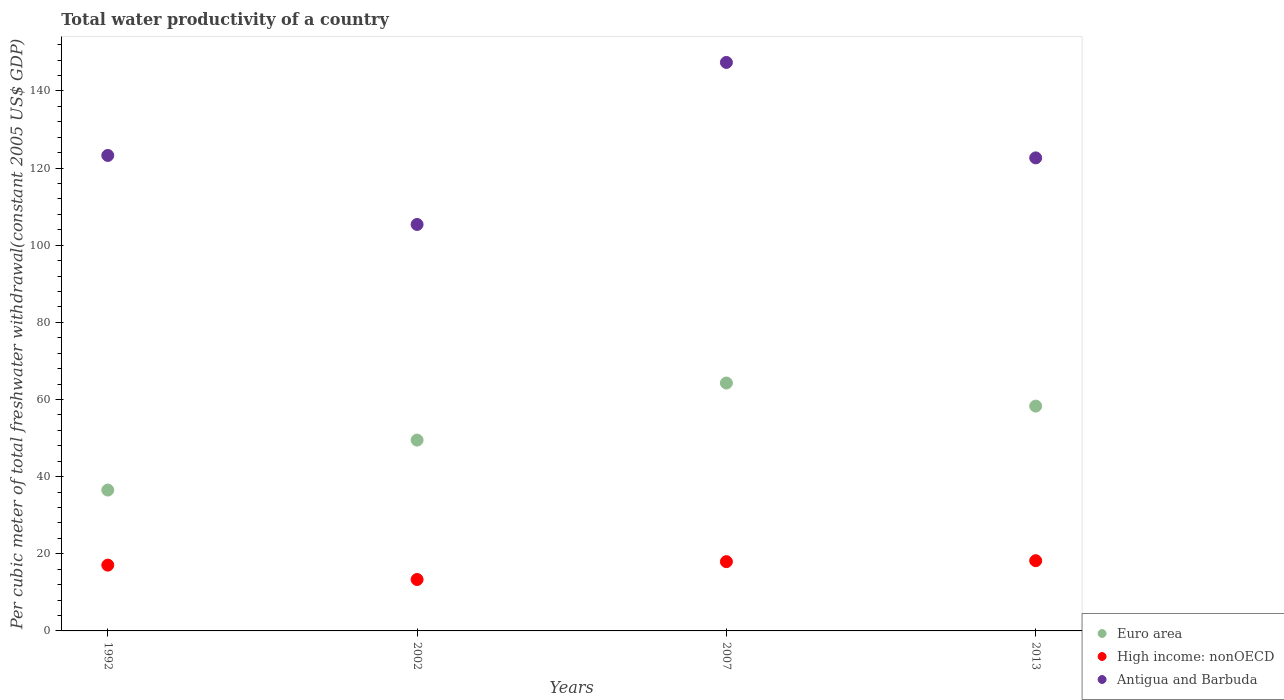How many different coloured dotlines are there?
Make the answer very short. 3. What is the total water productivity in High income: nonOECD in 2002?
Make the answer very short. 13.33. Across all years, what is the maximum total water productivity in Antigua and Barbuda?
Make the answer very short. 147.4. Across all years, what is the minimum total water productivity in Antigua and Barbuda?
Your answer should be compact. 105.39. In which year was the total water productivity in Antigua and Barbuda minimum?
Your answer should be very brief. 2002. What is the total total water productivity in Antigua and Barbuda in the graph?
Keep it short and to the point. 498.73. What is the difference between the total water productivity in Antigua and Barbuda in 1992 and that in 2002?
Provide a succinct answer. 17.89. What is the difference between the total water productivity in Antigua and Barbuda in 2002 and the total water productivity in Euro area in 1992?
Make the answer very short. 68.87. What is the average total water productivity in Antigua and Barbuda per year?
Offer a terse response. 124.68. In the year 2002, what is the difference between the total water productivity in Euro area and total water productivity in High income: nonOECD?
Ensure brevity in your answer.  36.15. In how many years, is the total water productivity in Antigua and Barbuda greater than 60 US$?
Give a very brief answer. 4. What is the ratio of the total water productivity in Euro area in 2002 to that in 2013?
Your answer should be very brief. 0.85. Is the total water productivity in High income: nonOECD in 2002 less than that in 2013?
Offer a very short reply. Yes. What is the difference between the highest and the second highest total water productivity in High income: nonOECD?
Your answer should be very brief. 0.25. What is the difference between the highest and the lowest total water productivity in High income: nonOECD?
Give a very brief answer. 4.87. In how many years, is the total water productivity in Euro area greater than the average total water productivity in Euro area taken over all years?
Provide a succinct answer. 2. Is the sum of the total water productivity in Antigua and Barbuda in 1992 and 2002 greater than the maximum total water productivity in Euro area across all years?
Your answer should be very brief. Yes. Is it the case that in every year, the sum of the total water productivity in High income: nonOECD and total water productivity in Euro area  is greater than the total water productivity in Antigua and Barbuda?
Provide a short and direct response. No. Does the total water productivity in High income: nonOECD monotonically increase over the years?
Your response must be concise. No. Is the total water productivity in Antigua and Barbuda strictly greater than the total water productivity in High income: nonOECD over the years?
Provide a short and direct response. Yes. How many dotlines are there?
Offer a very short reply. 3. Does the graph contain any zero values?
Keep it short and to the point. No. How many legend labels are there?
Keep it short and to the point. 3. How are the legend labels stacked?
Keep it short and to the point. Vertical. What is the title of the graph?
Provide a succinct answer. Total water productivity of a country. Does "Cote d'Ivoire" appear as one of the legend labels in the graph?
Your answer should be very brief. No. What is the label or title of the Y-axis?
Make the answer very short. Per cubic meter of total freshwater withdrawal(constant 2005 US$ GDP). What is the Per cubic meter of total freshwater withdrawal(constant 2005 US$ GDP) of Euro area in 1992?
Provide a succinct answer. 36.52. What is the Per cubic meter of total freshwater withdrawal(constant 2005 US$ GDP) of High income: nonOECD in 1992?
Keep it short and to the point. 17.06. What is the Per cubic meter of total freshwater withdrawal(constant 2005 US$ GDP) in Antigua and Barbuda in 1992?
Your response must be concise. 123.28. What is the Per cubic meter of total freshwater withdrawal(constant 2005 US$ GDP) of Euro area in 2002?
Provide a succinct answer. 49.48. What is the Per cubic meter of total freshwater withdrawal(constant 2005 US$ GDP) in High income: nonOECD in 2002?
Keep it short and to the point. 13.33. What is the Per cubic meter of total freshwater withdrawal(constant 2005 US$ GDP) in Antigua and Barbuda in 2002?
Provide a succinct answer. 105.39. What is the Per cubic meter of total freshwater withdrawal(constant 2005 US$ GDP) in Euro area in 2007?
Your answer should be very brief. 64.27. What is the Per cubic meter of total freshwater withdrawal(constant 2005 US$ GDP) of High income: nonOECD in 2007?
Give a very brief answer. 17.96. What is the Per cubic meter of total freshwater withdrawal(constant 2005 US$ GDP) in Antigua and Barbuda in 2007?
Give a very brief answer. 147.4. What is the Per cubic meter of total freshwater withdrawal(constant 2005 US$ GDP) in Euro area in 2013?
Your answer should be compact. 58.3. What is the Per cubic meter of total freshwater withdrawal(constant 2005 US$ GDP) in High income: nonOECD in 2013?
Your answer should be compact. 18.21. What is the Per cubic meter of total freshwater withdrawal(constant 2005 US$ GDP) in Antigua and Barbuda in 2013?
Provide a succinct answer. 122.66. Across all years, what is the maximum Per cubic meter of total freshwater withdrawal(constant 2005 US$ GDP) in Euro area?
Ensure brevity in your answer.  64.27. Across all years, what is the maximum Per cubic meter of total freshwater withdrawal(constant 2005 US$ GDP) of High income: nonOECD?
Provide a succinct answer. 18.21. Across all years, what is the maximum Per cubic meter of total freshwater withdrawal(constant 2005 US$ GDP) in Antigua and Barbuda?
Offer a very short reply. 147.4. Across all years, what is the minimum Per cubic meter of total freshwater withdrawal(constant 2005 US$ GDP) of Euro area?
Keep it short and to the point. 36.52. Across all years, what is the minimum Per cubic meter of total freshwater withdrawal(constant 2005 US$ GDP) of High income: nonOECD?
Offer a very short reply. 13.33. Across all years, what is the minimum Per cubic meter of total freshwater withdrawal(constant 2005 US$ GDP) of Antigua and Barbuda?
Keep it short and to the point. 105.39. What is the total Per cubic meter of total freshwater withdrawal(constant 2005 US$ GDP) in Euro area in the graph?
Give a very brief answer. 208.57. What is the total Per cubic meter of total freshwater withdrawal(constant 2005 US$ GDP) of High income: nonOECD in the graph?
Provide a short and direct response. 66.56. What is the total Per cubic meter of total freshwater withdrawal(constant 2005 US$ GDP) in Antigua and Barbuda in the graph?
Offer a terse response. 498.73. What is the difference between the Per cubic meter of total freshwater withdrawal(constant 2005 US$ GDP) in Euro area in 1992 and that in 2002?
Your response must be concise. -12.96. What is the difference between the Per cubic meter of total freshwater withdrawal(constant 2005 US$ GDP) in High income: nonOECD in 1992 and that in 2002?
Make the answer very short. 3.72. What is the difference between the Per cubic meter of total freshwater withdrawal(constant 2005 US$ GDP) in Antigua and Barbuda in 1992 and that in 2002?
Provide a short and direct response. 17.89. What is the difference between the Per cubic meter of total freshwater withdrawal(constant 2005 US$ GDP) in Euro area in 1992 and that in 2007?
Keep it short and to the point. -27.75. What is the difference between the Per cubic meter of total freshwater withdrawal(constant 2005 US$ GDP) of High income: nonOECD in 1992 and that in 2007?
Provide a succinct answer. -0.9. What is the difference between the Per cubic meter of total freshwater withdrawal(constant 2005 US$ GDP) in Antigua and Barbuda in 1992 and that in 2007?
Ensure brevity in your answer.  -24.12. What is the difference between the Per cubic meter of total freshwater withdrawal(constant 2005 US$ GDP) in Euro area in 1992 and that in 2013?
Make the answer very short. -21.77. What is the difference between the Per cubic meter of total freshwater withdrawal(constant 2005 US$ GDP) of High income: nonOECD in 1992 and that in 2013?
Give a very brief answer. -1.15. What is the difference between the Per cubic meter of total freshwater withdrawal(constant 2005 US$ GDP) of Antigua and Barbuda in 1992 and that in 2013?
Keep it short and to the point. 0.63. What is the difference between the Per cubic meter of total freshwater withdrawal(constant 2005 US$ GDP) of Euro area in 2002 and that in 2007?
Give a very brief answer. -14.79. What is the difference between the Per cubic meter of total freshwater withdrawal(constant 2005 US$ GDP) in High income: nonOECD in 2002 and that in 2007?
Offer a terse response. -4.63. What is the difference between the Per cubic meter of total freshwater withdrawal(constant 2005 US$ GDP) of Antigua and Barbuda in 2002 and that in 2007?
Ensure brevity in your answer.  -42.02. What is the difference between the Per cubic meter of total freshwater withdrawal(constant 2005 US$ GDP) of Euro area in 2002 and that in 2013?
Provide a succinct answer. -8.82. What is the difference between the Per cubic meter of total freshwater withdrawal(constant 2005 US$ GDP) in High income: nonOECD in 2002 and that in 2013?
Make the answer very short. -4.87. What is the difference between the Per cubic meter of total freshwater withdrawal(constant 2005 US$ GDP) of Antigua and Barbuda in 2002 and that in 2013?
Keep it short and to the point. -17.27. What is the difference between the Per cubic meter of total freshwater withdrawal(constant 2005 US$ GDP) of Euro area in 2007 and that in 2013?
Offer a terse response. 5.98. What is the difference between the Per cubic meter of total freshwater withdrawal(constant 2005 US$ GDP) of High income: nonOECD in 2007 and that in 2013?
Make the answer very short. -0.25. What is the difference between the Per cubic meter of total freshwater withdrawal(constant 2005 US$ GDP) in Antigua and Barbuda in 2007 and that in 2013?
Ensure brevity in your answer.  24.75. What is the difference between the Per cubic meter of total freshwater withdrawal(constant 2005 US$ GDP) in Euro area in 1992 and the Per cubic meter of total freshwater withdrawal(constant 2005 US$ GDP) in High income: nonOECD in 2002?
Your answer should be compact. 23.19. What is the difference between the Per cubic meter of total freshwater withdrawal(constant 2005 US$ GDP) of Euro area in 1992 and the Per cubic meter of total freshwater withdrawal(constant 2005 US$ GDP) of Antigua and Barbuda in 2002?
Keep it short and to the point. -68.87. What is the difference between the Per cubic meter of total freshwater withdrawal(constant 2005 US$ GDP) of High income: nonOECD in 1992 and the Per cubic meter of total freshwater withdrawal(constant 2005 US$ GDP) of Antigua and Barbuda in 2002?
Make the answer very short. -88.33. What is the difference between the Per cubic meter of total freshwater withdrawal(constant 2005 US$ GDP) in Euro area in 1992 and the Per cubic meter of total freshwater withdrawal(constant 2005 US$ GDP) in High income: nonOECD in 2007?
Ensure brevity in your answer.  18.56. What is the difference between the Per cubic meter of total freshwater withdrawal(constant 2005 US$ GDP) of Euro area in 1992 and the Per cubic meter of total freshwater withdrawal(constant 2005 US$ GDP) of Antigua and Barbuda in 2007?
Ensure brevity in your answer.  -110.88. What is the difference between the Per cubic meter of total freshwater withdrawal(constant 2005 US$ GDP) in High income: nonOECD in 1992 and the Per cubic meter of total freshwater withdrawal(constant 2005 US$ GDP) in Antigua and Barbuda in 2007?
Provide a succinct answer. -130.35. What is the difference between the Per cubic meter of total freshwater withdrawal(constant 2005 US$ GDP) in Euro area in 1992 and the Per cubic meter of total freshwater withdrawal(constant 2005 US$ GDP) in High income: nonOECD in 2013?
Keep it short and to the point. 18.31. What is the difference between the Per cubic meter of total freshwater withdrawal(constant 2005 US$ GDP) of Euro area in 1992 and the Per cubic meter of total freshwater withdrawal(constant 2005 US$ GDP) of Antigua and Barbuda in 2013?
Your answer should be compact. -86.13. What is the difference between the Per cubic meter of total freshwater withdrawal(constant 2005 US$ GDP) in High income: nonOECD in 1992 and the Per cubic meter of total freshwater withdrawal(constant 2005 US$ GDP) in Antigua and Barbuda in 2013?
Your answer should be very brief. -105.6. What is the difference between the Per cubic meter of total freshwater withdrawal(constant 2005 US$ GDP) in Euro area in 2002 and the Per cubic meter of total freshwater withdrawal(constant 2005 US$ GDP) in High income: nonOECD in 2007?
Offer a terse response. 31.52. What is the difference between the Per cubic meter of total freshwater withdrawal(constant 2005 US$ GDP) in Euro area in 2002 and the Per cubic meter of total freshwater withdrawal(constant 2005 US$ GDP) in Antigua and Barbuda in 2007?
Provide a short and direct response. -97.92. What is the difference between the Per cubic meter of total freshwater withdrawal(constant 2005 US$ GDP) of High income: nonOECD in 2002 and the Per cubic meter of total freshwater withdrawal(constant 2005 US$ GDP) of Antigua and Barbuda in 2007?
Make the answer very short. -134.07. What is the difference between the Per cubic meter of total freshwater withdrawal(constant 2005 US$ GDP) of Euro area in 2002 and the Per cubic meter of total freshwater withdrawal(constant 2005 US$ GDP) of High income: nonOECD in 2013?
Provide a succinct answer. 31.27. What is the difference between the Per cubic meter of total freshwater withdrawal(constant 2005 US$ GDP) in Euro area in 2002 and the Per cubic meter of total freshwater withdrawal(constant 2005 US$ GDP) in Antigua and Barbuda in 2013?
Make the answer very short. -73.18. What is the difference between the Per cubic meter of total freshwater withdrawal(constant 2005 US$ GDP) in High income: nonOECD in 2002 and the Per cubic meter of total freshwater withdrawal(constant 2005 US$ GDP) in Antigua and Barbuda in 2013?
Ensure brevity in your answer.  -109.32. What is the difference between the Per cubic meter of total freshwater withdrawal(constant 2005 US$ GDP) in Euro area in 2007 and the Per cubic meter of total freshwater withdrawal(constant 2005 US$ GDP) in High income: nonOECD in 2013?
Provide a short and direct response. 46.07. What is the difference between the Per cubic meter of total freshwater withdrawal(constant 2005 US$ GDP) of Euro area in 2007 and the Per cubic meter of total freshwater withdrawal(constant 2005 US$ GDP) of Antigua and Barbuda in 2013?
Your answer should be compact. -58.38. What is the difference between the Per cubic meter of total freshwater withdrawal(constant 2005 US$ GDP) in High income: nonOECD in 2007 and the Per cubic meter of total freshwater withdrawal(constant 2005 US$ GDP) in Antigua and Barbuda in 2013?
Make the answer very short. -104.69. What is the average Per cubic meter of total freshwater withdrawal(constant 2005 US$ GDP) of Euro area per year?
Provide a succinct answer. 52.14. What is the average Per cubic meter of total freshwater withdrawal(constant 2005 US$ GDP) in High income: nonOECD per year?
Make the answer very short. 16.64. What is the average Per cubic meter of total freshwater withdrawal(constant 2005 US$ GDP) of Antigua and Barbuda per year?
Keep it short and to the point. 124.68. In the year 1992, what is the difference between the Per cubic meter of total freshwater withdrawal(constant 2005 US$ GDP) of Euro area and Per cubic meter of total freshwater withdrawal(constant 2005 US$ GDP) of High income: nonOECD?
Your answer should be very brief. 19.46. In the year 1992, what is the difference between the Per cubic meter of total freshwater withdrawal(constant 2005 US$ GDP) of Euro area and Per cubic meter of total freshwater withdrawal(constant 2005 US$ GDP) of Antigua and Barbuda?
Offer a terse response. -86.76. In the year 1992, what is the difference between the Per cubic meter of total freshwater withdrawal(constant 2005 US$ GDP) of High income: nonOECD and Per cubic meter of total freshwater withdrawal(constant 2005 US$ GDP) of Antigua and Barbuda?
Your answer should be compact. -106.22. In the year 2002, what is the difference between the Per cubic meter of total freshwater withdrawal(constant 2005 US$ GDP) of Euro area and Per cubic meter of total freshwater withdrawal(constant 2005 US$ GDP) of High income: nonOECD?
Your response must be concise. 36.15. In the year 2002, what is the difference between the Per cubic meter of total freshwater withdrawal(constant 2005 US$ GDP) of Euro area and Per cubic meter of total freshwater withdrawal(constant 2005 US$ GDP) of Antigua and Barbuda?
Provide a short and direct response. -55.91. In the year 2002, what is the difference between the Per cubic meter of total freshwater withdrawal(constant 2005 US$ GDP) in High income: nonOECD and Per cubic meter of total freshwater withdrawal(constant 2005 US$ GDP) in Antigua and Barbuda?
Your response must be concise. -92.06. In the year 2007, what is the difference between the Per cubic meter of total freshwater withdrawal(constant 2005 US$ GDP) in Euro area and Per cubic meter of total freshwater withdrawal(constant 2005 US$ GDP) in High income: nonOECD?
Ensure brevity in your answer.  46.31. In the year 2007, what is the difference between the Per cubic meter of total freshwater withdrawal(constant 2005 US$ GDP) of Euro area and Per cubic meter of total freshwater withdrawal(constant 2005 US$ GDP) of Antigua and Barbuda?
Offer a very short reply. -83.13. In the year 2007, what is the difference between the Per cubic meter of total freshwater withdrawal(constant 2005 US$ GDP) of High income: nonOECD and Per cubic meter of total freshwater withdrawal(constant 2005 US$ GDP) of Antigua and Barbuda?
Your answer should be very brief. -129.44. In the year 2013, what is the difference between the Per cubic meter of total freshwater withdrawal(constant 2005 US$ GDP) in Euro area and Per cubic meter of total freshwater withdrawal(constant 2005 US$ GDP) in High income: nonOECD?
Your response must be concise. 40.09. In the year 2013, what is the difference between the Per cubic meter of total freshwater withdrawal(constant 2005 US$ GDP) of Euro area and Per cubic meter of total freshwater withdrawal(constant 2005 US$ GDP) of Antigua and Barbuda?
Your response must be concise. -64.36. In the year 2013, what is the difference between the Per cubic meter of total freshwater withdrawal(constant 2005 US$ GDP) of High income: nonOECD and Per cubic meter of total freshwater withdrawal(constant 2005 US$ GDP) of Antigua and Barbuda?
Your answer should be very brief. -104.45. What is the ratio of the Per cubic meter of total freshwater withdrawal(constant 2005 US$ GDP) of Euro area in 1992 to that in 2002?
Offer a terse response. 0.74. What is the ratio of the Per cubic meter of total freshwater withdrawal(constant 2005 US$ GDP) of High income: nonOECD in 1992 to that in 2002?
Keep it short and to the point. 1.28. What is the ratio of the Per cubic meter of total freshwater withdrawal(constant 2005 US$ GDP) of Antigua and Barbuda in 1992 to that in 2002?
Your response must be concise. 1.17. What is the ratio of the Per cubic meter of total freshwater withdrawal(constant 2005 US$ GDP) of Euro area in 1992 to that in 2007?
Make the answer very short. 0.57. What is the ratio of the Per cubic meter of total freshwater withdrawal(constant 2005 US$ GDP) of High income: nonOECD in 1992 to that in 2007?
Your answer should be very brief. 0.95. What is the ratio of the Per cubic meter of total freshwater withdrawal(constant 2005 US$ GDP) in Antigua and Barbuda in 1992 to that in 2007?
Provide a succinct answer. 0.84. What is the ratio of the Per cubic meter of total freshwater withdrawal(constant 2005 US$ GDP) of Euro area in 1992 to that in 2013?
Keep it short and to the point. 0.63. What is the ratio of the Per cubic meter of total freshwater withdrawal(constant 2005 US$ GDP) of High income: nonOECD in 1992 to that in 2013?
Your answer should be compact. 0.94. What is the ratio of the Per cubic meter of total freshwater withdrawal(constant 2005 US$ GDP) in Antigua and Barbuda in 1992 to that in 2013?
Your answer should be compact. 1.01. What is the ratio of the Per cubic meter of total freshwater withdrawal(constant 2005 US$ GDP) of Euro area in 2002 to that in 2007?
Offer a terse response. 0.77. What is the ratio of the Per cubic meter of total freshwater withdrawal(constant 2005 US$ GDP) of High income: nonOECD in 2002 to that in 2007?
Provide a short and direct response. 0.74. What is the ratio of the Per cubic meter of total freshwater withdrawal(constant 2005 US$ GDP) of Antigua and Barbuda in 2002 to that in 2007?
Your answer should be compact. 0.71. What is the ratio of the Per cubic meter of total freshwater withdrawal(constant 2005 US$ GDP) of Euro area in 2002 to that in 2013?
Make the answer very short. 0.85. What is the ratio of the Per cubic meter of total freshwater withdrawal(constant 2005 US$ GDP) of High income: nonOECD in 2002 to that in 2013?
Give a very brief answer. 0.73. What is the ratio of the Per cubic meter of total freshwater withdrawal(constant 2005 US$ GDP) of Antigua and Barbuda in 2002 to that in 2013?
Offer a very short reply. 0.86. What is the ratio of the Per cubic meter of total freshwater withdrawal(constant 2005 US$ GDP) of Euro area in 2007 to that in 2013?
Ensure brevity in your answer.  1.1. What is the ratio of the Per cubic meter of total freshwater withdrawal(constant 2005 US$ GDP) of High income: nonOECD in 2007 to that in 2013?
Offer a very short reply. 0.99. What is the ratio of the Per cubic meter of total freshwater withdrawal(constant 2005 US$ GDP) of Antigua and Barbuda in 2007 to that in 2013?
Make the answer very short. 1.2. What is the difference between the highest and the second highest Per cubic meter of total freshwater withdrawal(constant 2005 US$ GDP) in Euro area?
Your response must be concise. 5.98. What is the difference between the highest and the second highest Per cubic meter of total freshwater withdrawal(constant 2005 US$ GDP) of High income: nonOECD?
Make the answer very short. 0.25. What is the difference between the highest and the second highest Per cubic meter of total freshwater withdrawal(constant 2005 US$ GDP) in Antigua and Barbuda?
Offer a very short reply. 24.12. What is the difference between the highest and the lowest Per cubic meter of total freshwater withdrawal(constant 2005 US$ GDP) in Euro area?
Provide a succinct answer. 27.75. What is the difference between the highest and the lowest Per cubic meter of total freshwater withdrawal(constant 2005 US$ GDP) in High income: nonOECD?
Keep it short and to the point. 4.87. What is the difference between the highest and the lowest Per cubic meter of total freshwater withdrawal(constant 2005 US$ GDP) in Antigua and Barbuda?
Keep it short and to the point. 42.02. 